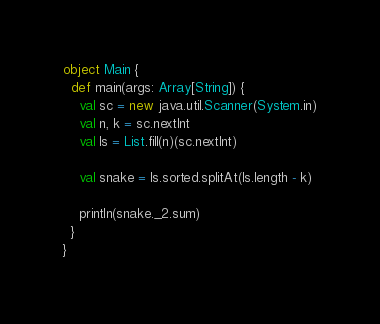<code> <loc_0><loc_0><loc_500><loc_500><_Scala_>object Main {
  def main(args: Array[String]) {
    val sc = new java.util.Scanner(System.in)
    val n, k = sc.nextInt
    val ls = List.fill(n)(sc.nextInt)

    val snake = ls.sorted.splitAt(ls.length - k)

    println(snake._2.sum)
  }
}
</code> 